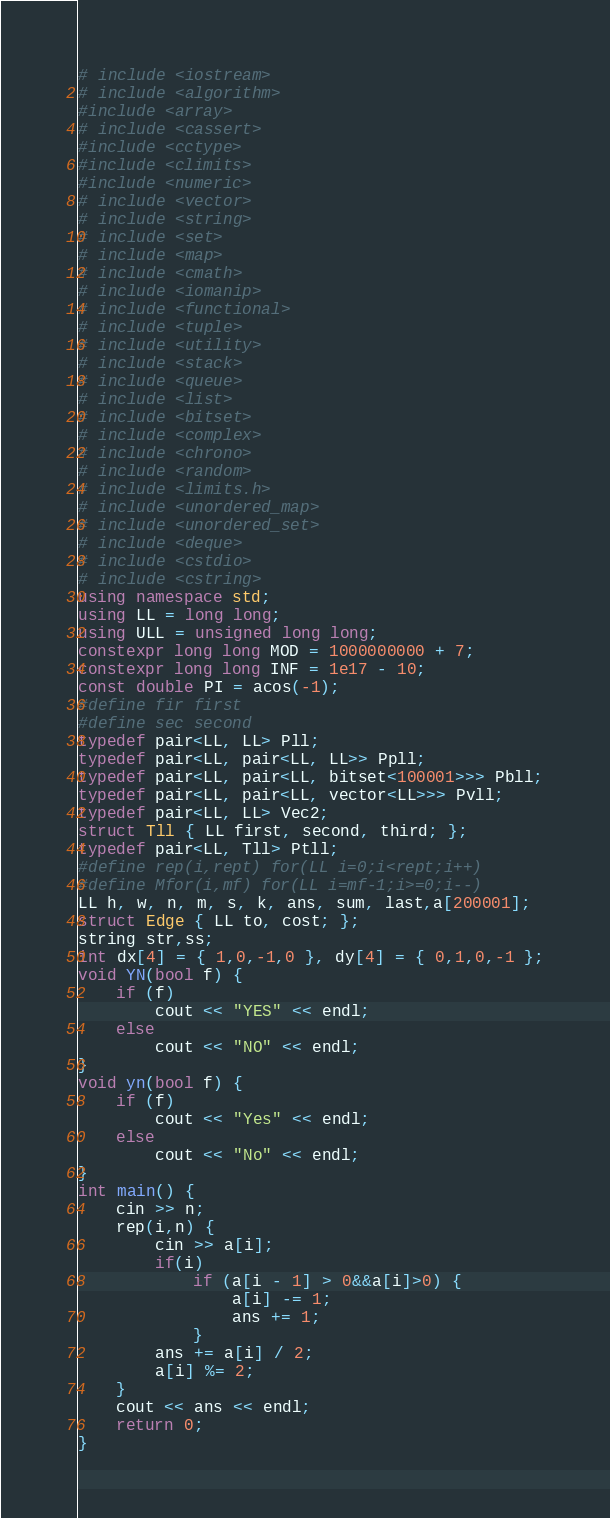<code> <loc_0><loc_0><loc_500><loc_500><_C++_># include <iostream>
# include <algorithm>
#include <array>
# include <cassert>
#include <cctype>
#include <climits>
#include <numeric>
# include <vector>
# include <string>
# include <set>
# include <map>
# include <cmath>
# include <iomanip>
# include <functional>
# include <tuple>
# include <utility>
# include <stack>
# include <queue>
# include <list>
# include <bitset>
# include <complex>
# include <chrono>
# include <random>
# include <limits.h>
# include <unordered_map>
# include <unordered_set>
# include <deque>
# include <cstdio>
# include <cstring>
using namespace std;
using LL = long long;
using ULL = unsigned long long;
constexpr long long MOD = 1000000000 + 7;
constexpr long long INF = 1e17 - 10;
const double PI = acos(-1);
#define fir first
#define sec second
typedef pair<LL, LL> Pll;
typedef pair<LL, pair<LL, LL>> Ppll;
typedef pair<LL, pair<LL, bitset<100001>>> Pbll;
typedef pair<LL, pair<LL, vector<LL>>> Pvll;
typedef pair<LL, LL> Vec2;
struct Tll { LL first, second, third; };
typedef pair<LL, Tll> Ptll;
#define rep(i,rept) for(LL i=0;i<rept;i++)
#define Mfor(i,mf) for(LL i=mf-1;i>=0;i--)
LL h, w, n, m, s, k, ans, sum, last,a[200001];
struct Edge { LL to, cost; }; 
string str,ss;
int dx[4] = { 1,0,-1,0 }, dy[4] = { 0,1,0,-1 };
void YN(bool f) {
	if (f)
		cout << "YES" << endl;
	else
		cout << "NO" << endl;
}
void yn(bool f) {
	if (f)
		cout << "Yes" << endl;
	else
		cout << "No" << endl;
}
int main() {
	cin >> n;
	rep(i,n) {
		cin >> a[i];
		if(i)
			if (a[i - 1] > 0&&a[i]>0) {
				a[i] -= 1;
				ans += 1;
			}
		ans += a[i] / 2;
		a[i] %= 2;
	}
	cout << ans << endl;
	return 0;
}
</code> 